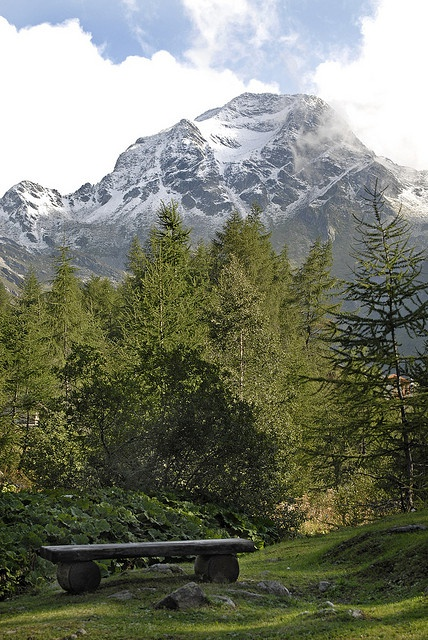Describe the objects in this image and their specific colors. I can see a bench in lavender, black, gray, darkgray, and darkgreen tones in this image. 